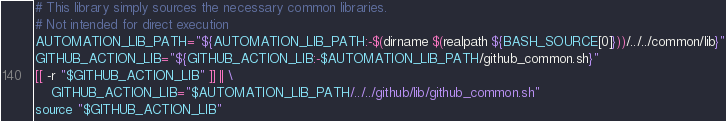Convert code to text. <code><loc_0><loc_0><loc_500><loc_500><_Bash_>
# This library simply sources the necessary common libraries.
# Not intended for direct execution
AUTOMATION_LIB_PATH="${AUTOMATION_LIB_PATH:-$(dirname $(realpath ${BASH_SOURCE[0]}))/../../common/lib}"
GITHUB_ACTION_LIB="${GITHUB_ACTION_LIB:-$AUTOMATION_LIB_PATH/github_common.sh}"
[[ -r "$GITHUB_ACTION_LIB" ]] || \
    GITHUB_ACTION_LIB="$AUTOMATION_LIB_PATH/../../github/lib/github_common.sh"
source "$GITHUB_ACTION_LIB"
</code> 